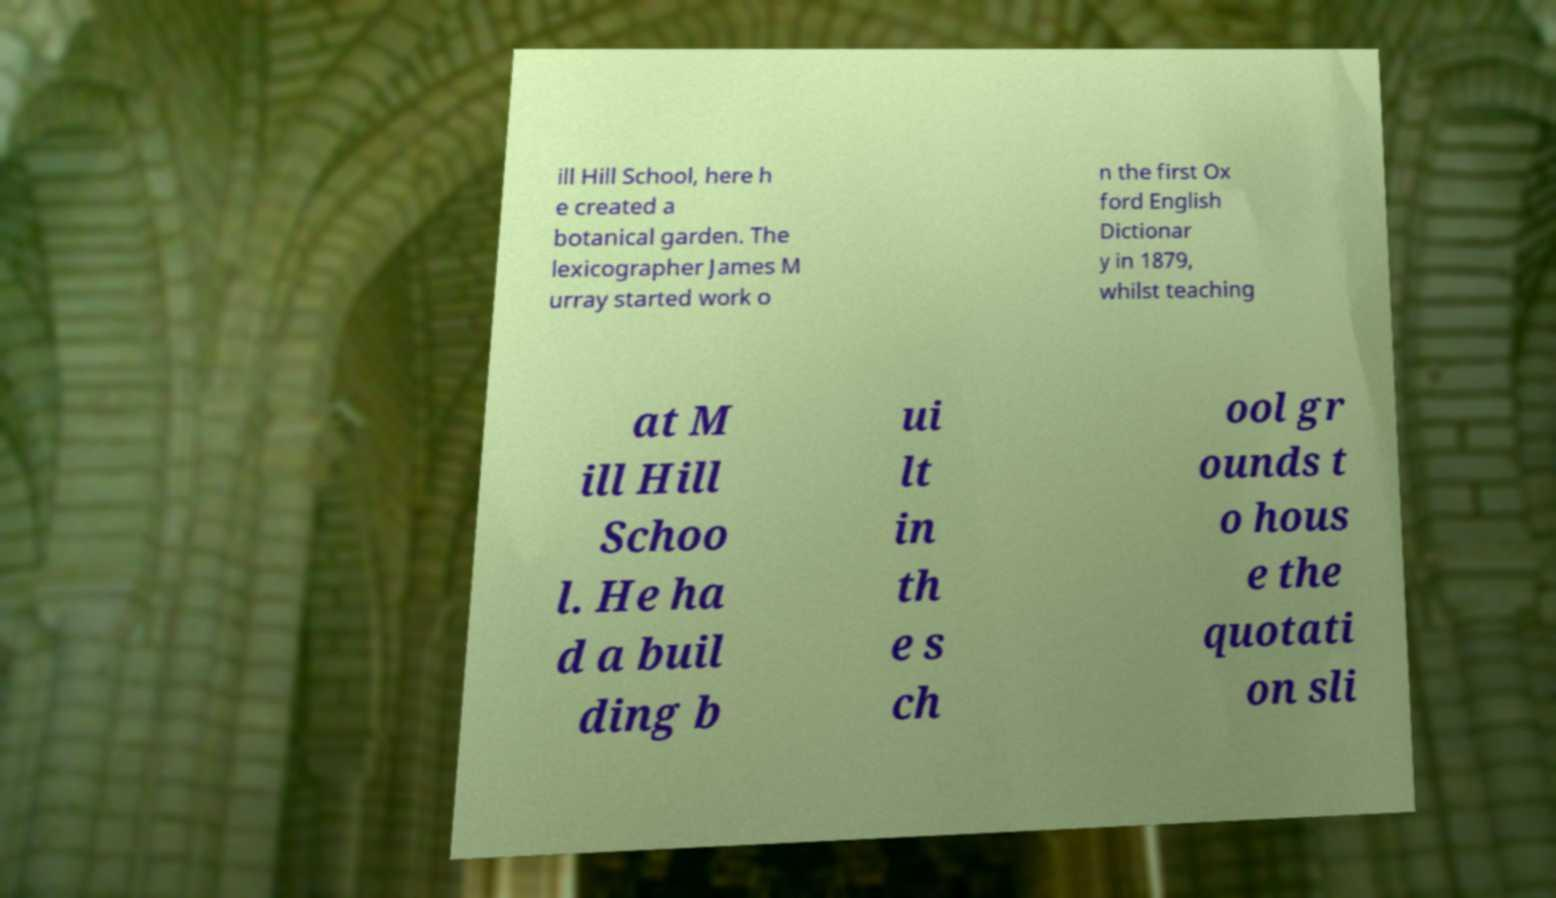What messages or text are displayed in this image? I need them in a readable, typed format. ill Hill School, here h e created a botanical garden. The lexicographer James M urray started work o n the first Ox ford English Dictionar y in 1879, whilst teaching at M ill Hill Schoo l. He ha d a buil ding b ui lt in th e s ch ool gr ounds t o hous e the quotati on sli 